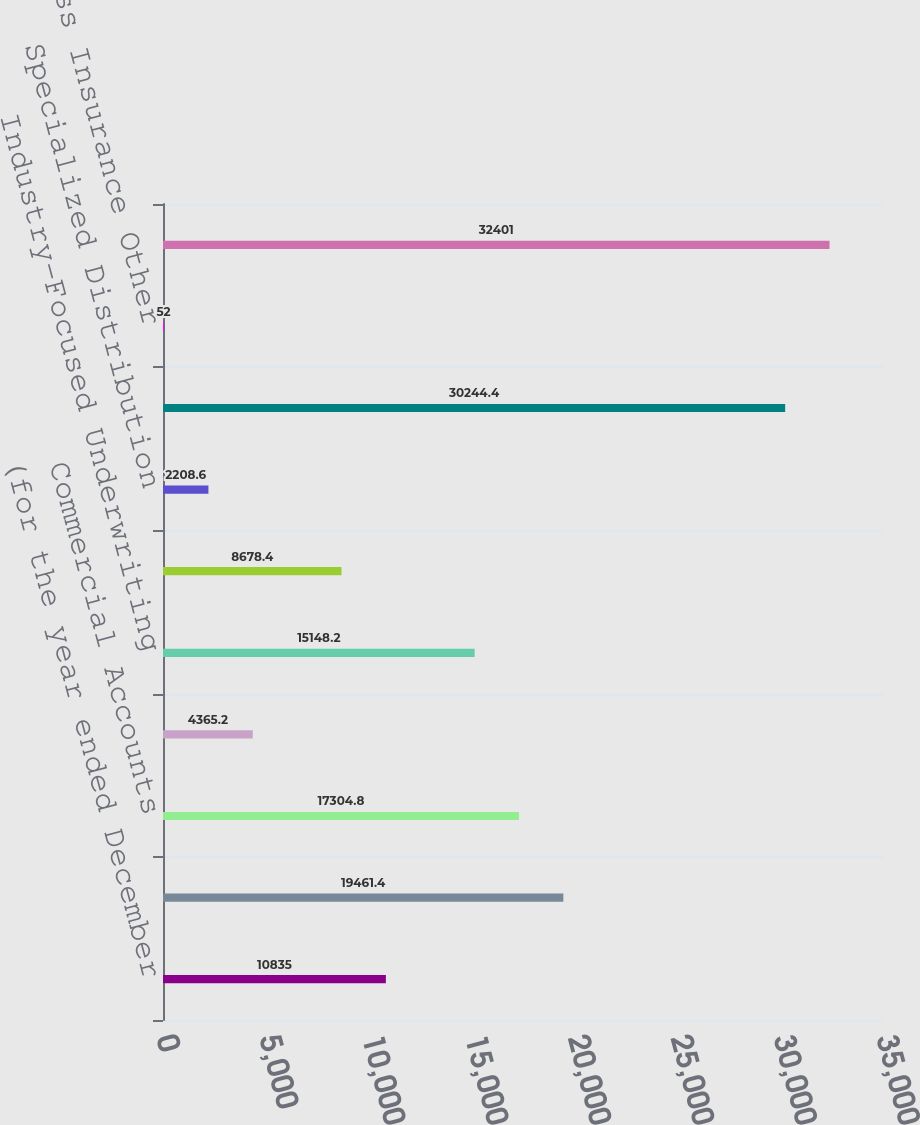<chart> <loc_0><loc_0><loc_500><loc_500><bar_chart><fcel>(for the year ended December<fcel>Select Accounts<fcel>Commercial Accounts<fcel>National Accounts<fcel>Industry-Focused Underwriting<fcel>Target Risk Underwriting<fcel>Specialized Distribution<fcel>Total Business Insurance Core<fcel>Business Insurance Other<fcel>Total Business Insurance<nl><fcel>10835<fcel>19461.4<fcel>17304.8<fcel>4365.2<fcel>15148.2<fcel>8678.4<fcel>2208.6<fcel>30244.4<fcel>52<fcel>32401<nl></chart> 